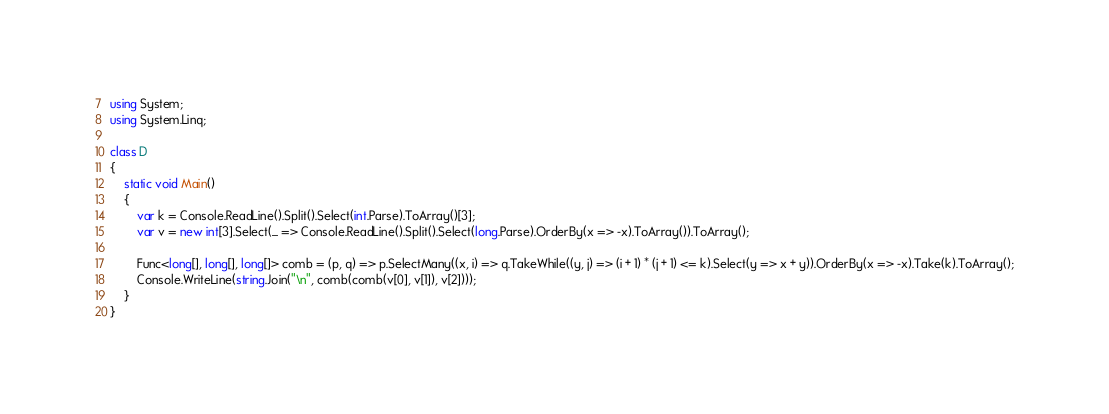Convert code to text. <code><loc_0><loc_0><loc_500><loc_500><_C#_>using System;
using System.Linq;

class D
{
	static void Main()
	{
		var k = Console.ReadLine().Split().Select(int.Parse).ToArray()[3];
		var v = new int[3].Select(_ => Console.ReadLine().Split().Select(long.Parse).OrderBy(x => -x).ToArray()).ToArray();

		Func<long[], long[], long[]> comb = (p, q) => p.SelectMany((x, i) => q.TakeWhile((y, j) => (i + 1) * (j + 1) <= k).Select(y => x + y)).OrderBy(x => -x).Take(k).ToArray();
		Console.WriteLine(string.Join("\n", comb(comb(v[0], v[1]), v[2])));
	}
}
</code> 